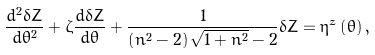Convert formula to latex. <formula><loc_0><loc_0><loc_500><loc_500>\frac { d ^ { 2 } \delta Z } { d \theta ^ { 2 } } + \zeta \frac { d \delta Z } { d \theta } + \frac { 1 } { \left ( n ^ { 2 } - 2 \right ) \sqrt { 1 + n ^ { 2 } } - 2 } \delta Z = \eta ^ { z } \left ( \theta \right ) ,</formula> 